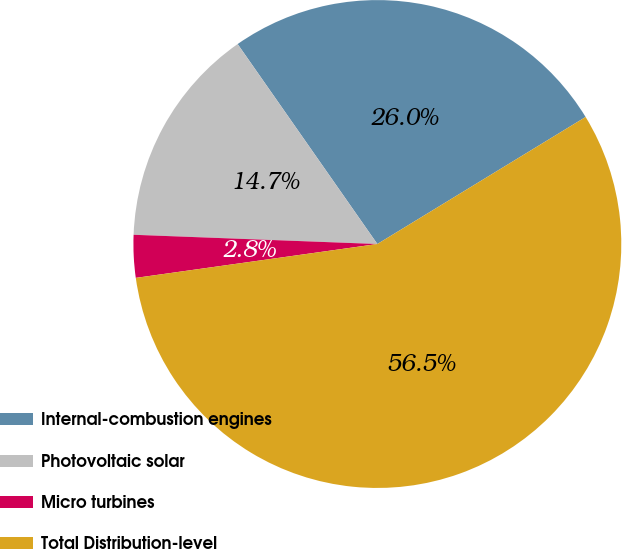Convert chart. <chart><loc_0><loc_0><loc_500><loc_500><pie_chart><fcel>Internal-combustion engines<fcel>Photovoltaic solar<fcel>Micro turbines<fcel>Total Distribution-level<nl><fcel>25.99%<fcel>14.69%<fcel>2.82%<fcel>56.5%<nl></chart> 